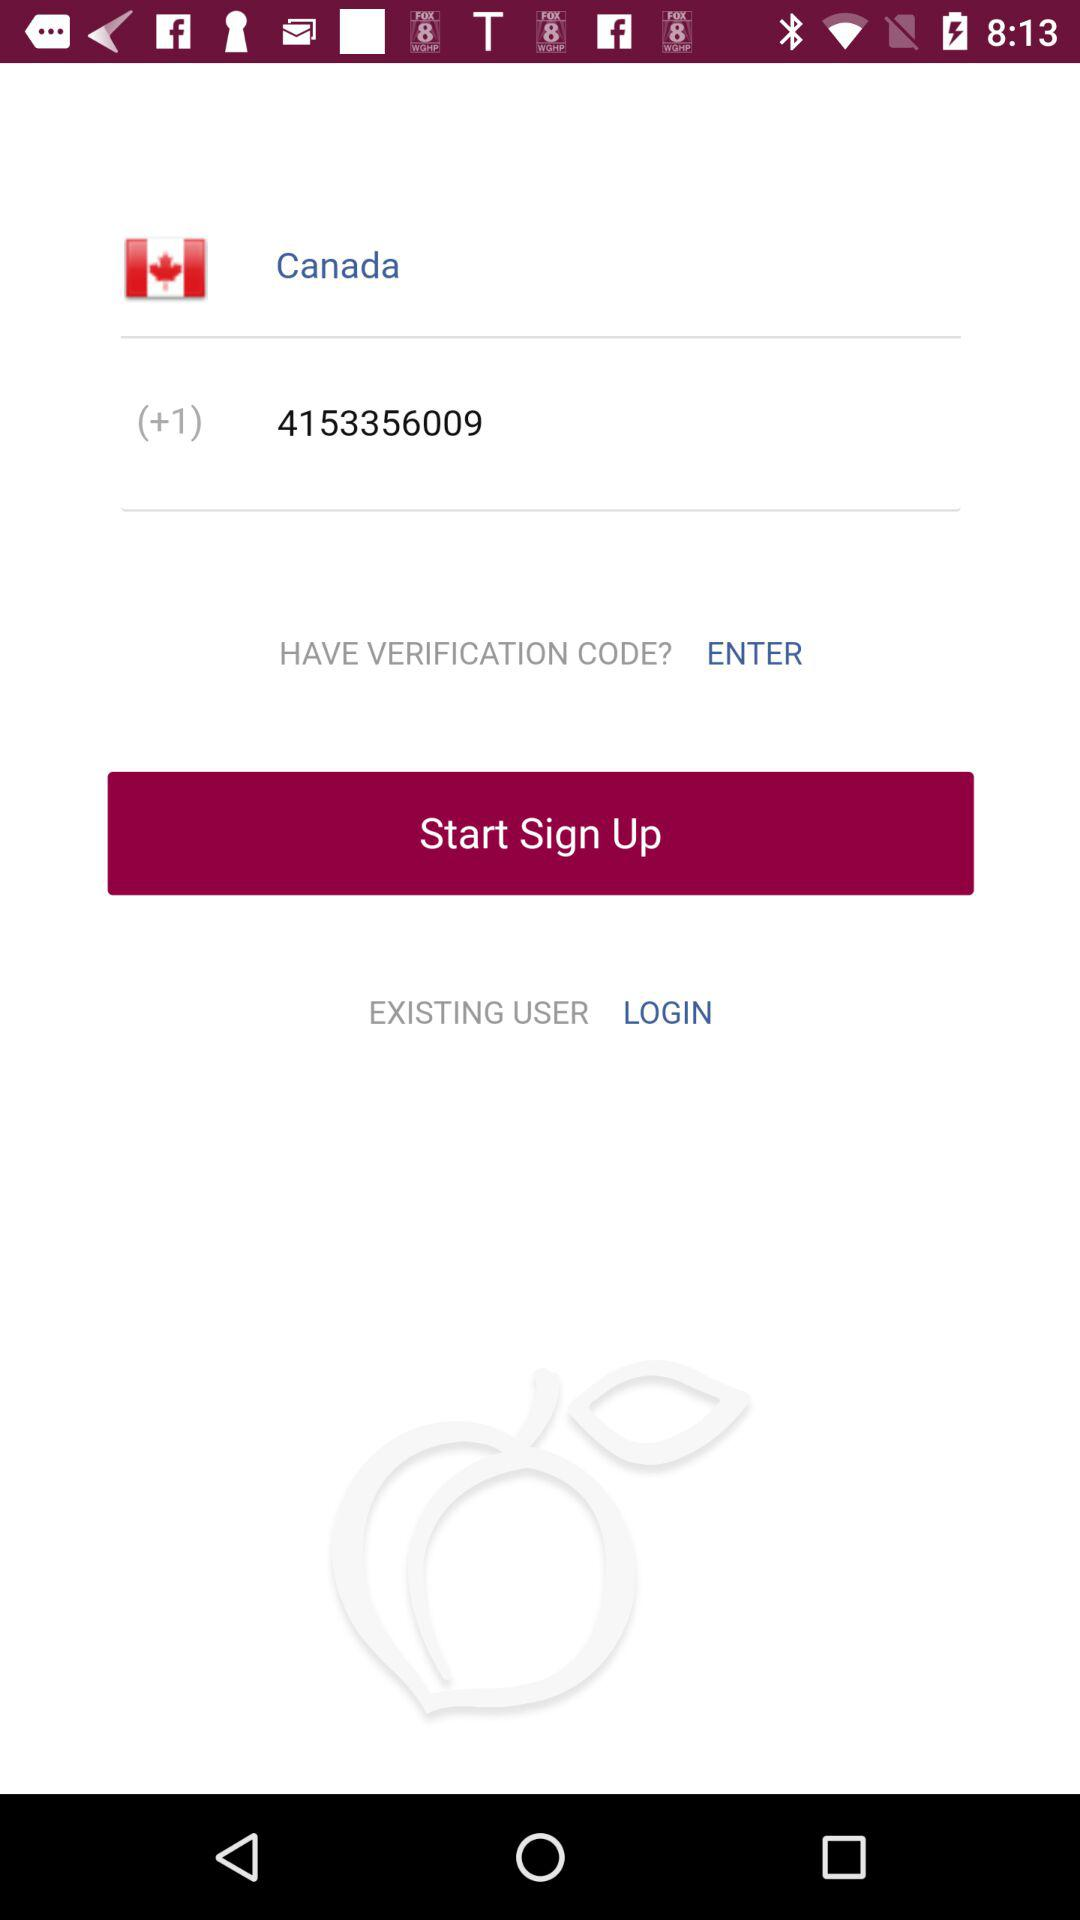What is the phone number? The phone number is (+1) 4153356009. 